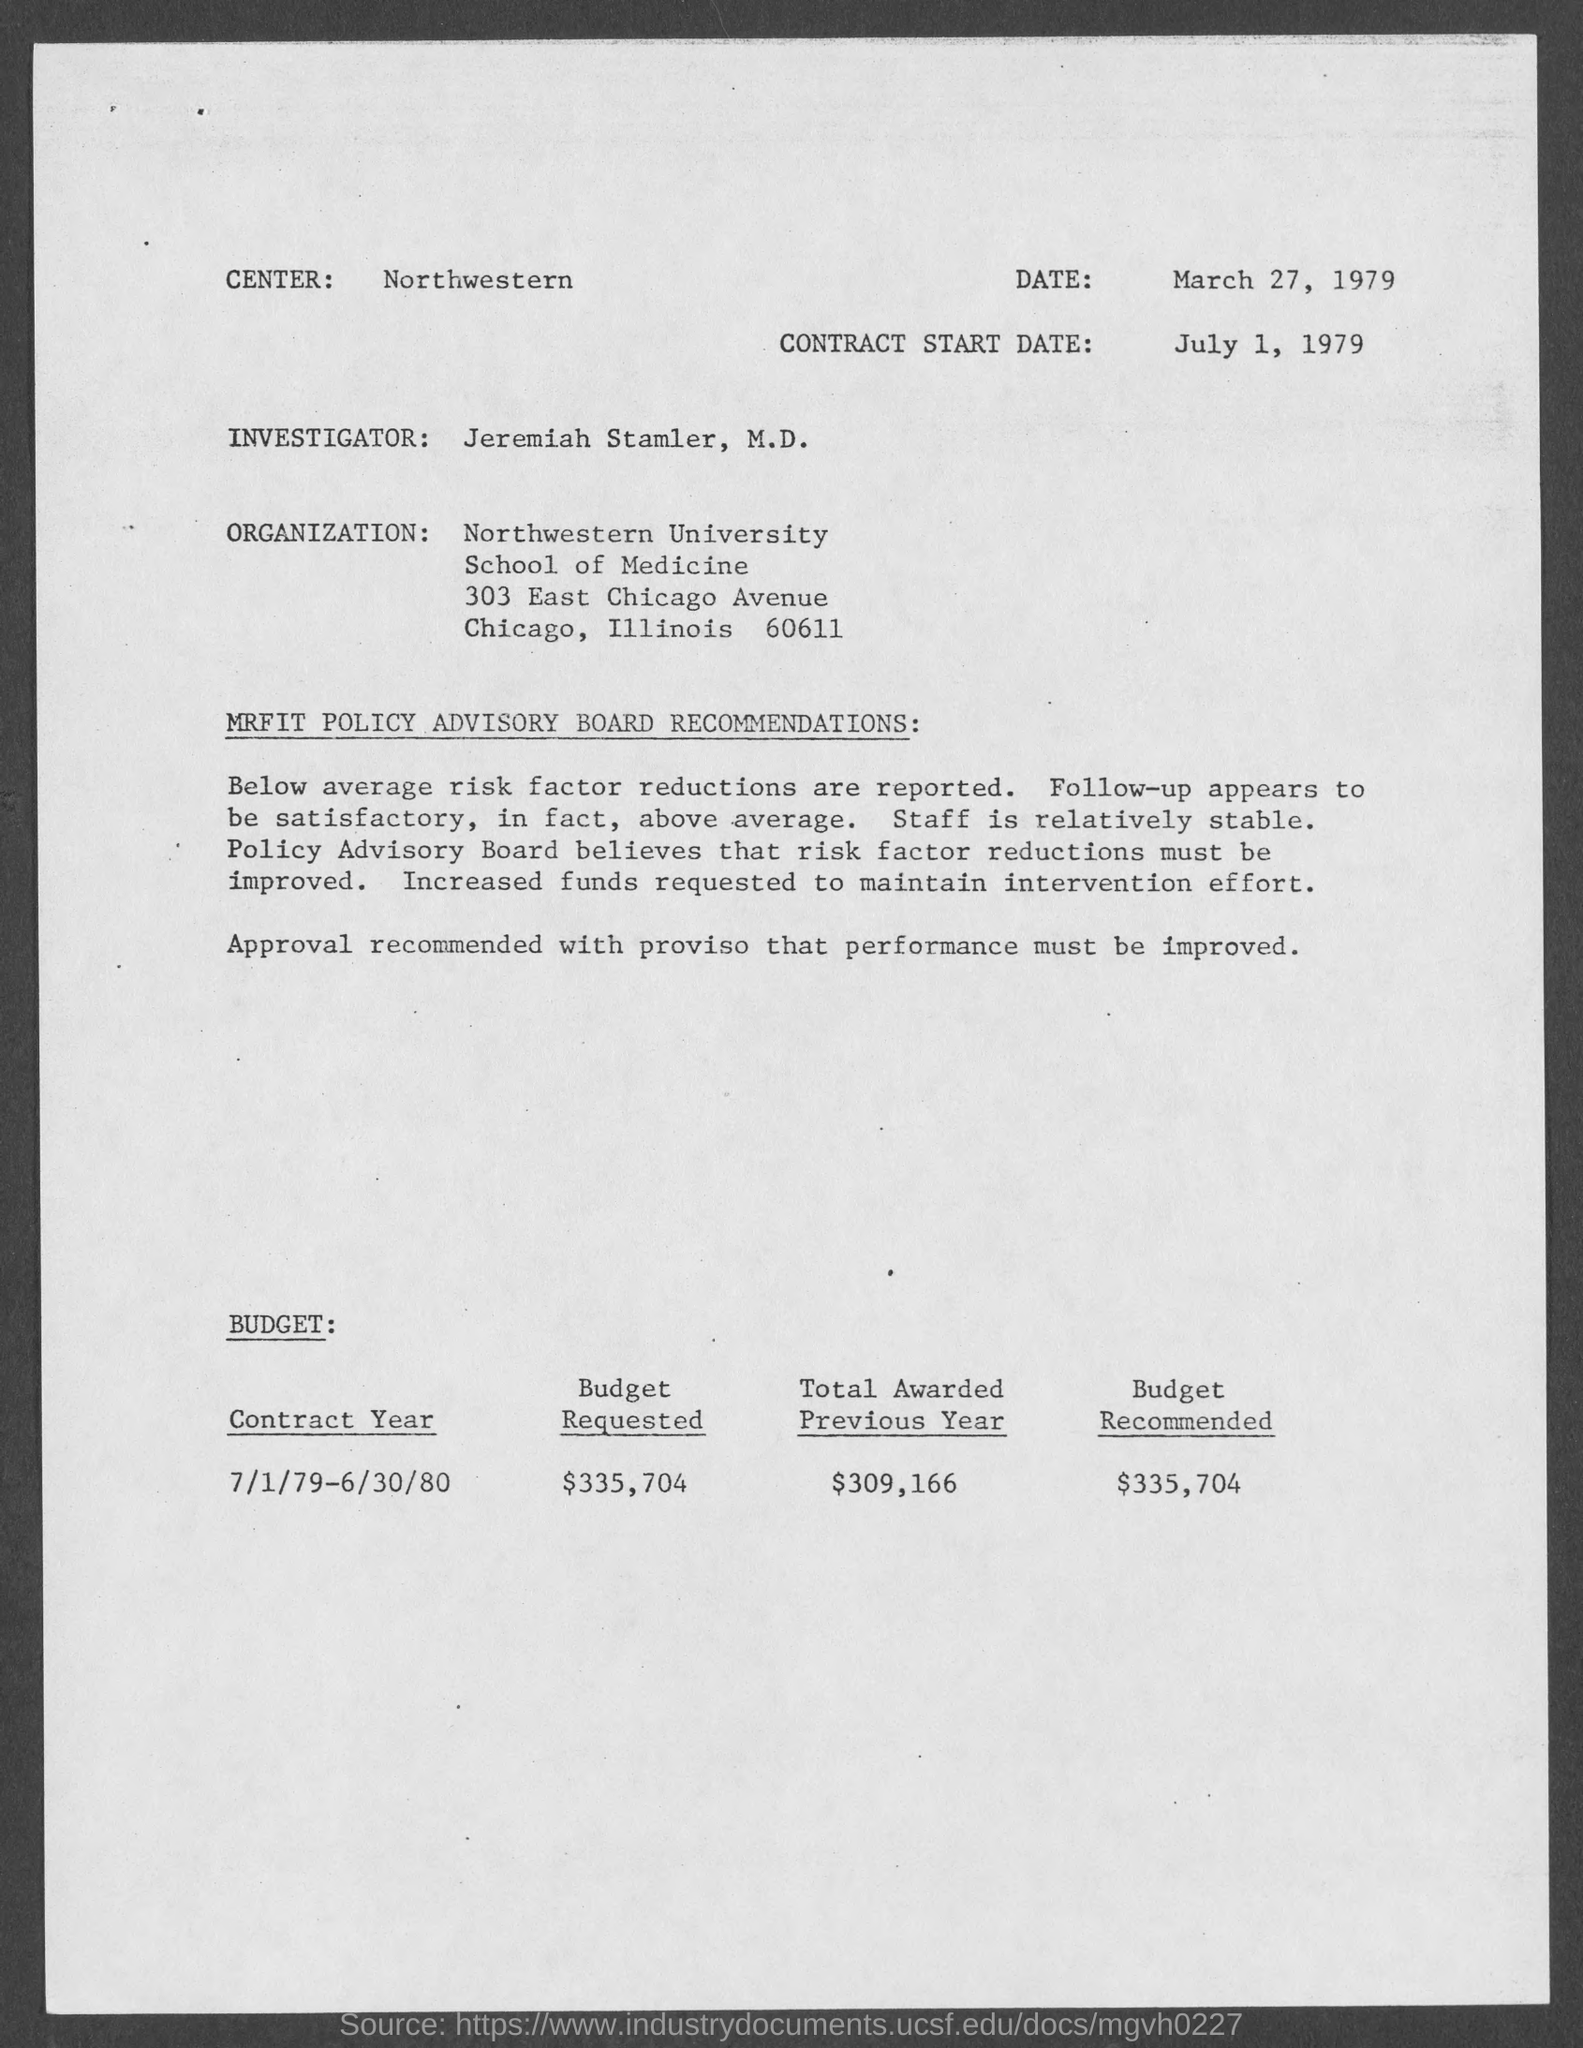Which is the center?
Your response must be concise. Northwestern. When is the document dated?
Provide a succinct answer. March 27, 1979. When is the contract start date?
Provide a short and direct response. July 1, 1979. Who is the investigator?
Your answer should be compact. Jeremiah Stamler. What is the Contract year specified?
Give a very brief answer. 7/1/79-6/30/80. What is the amount of Budget requested?
Offer a very short reply. $335,704. How much was "total awarded previous year"?
Your answer should be very brief. $309,166. 